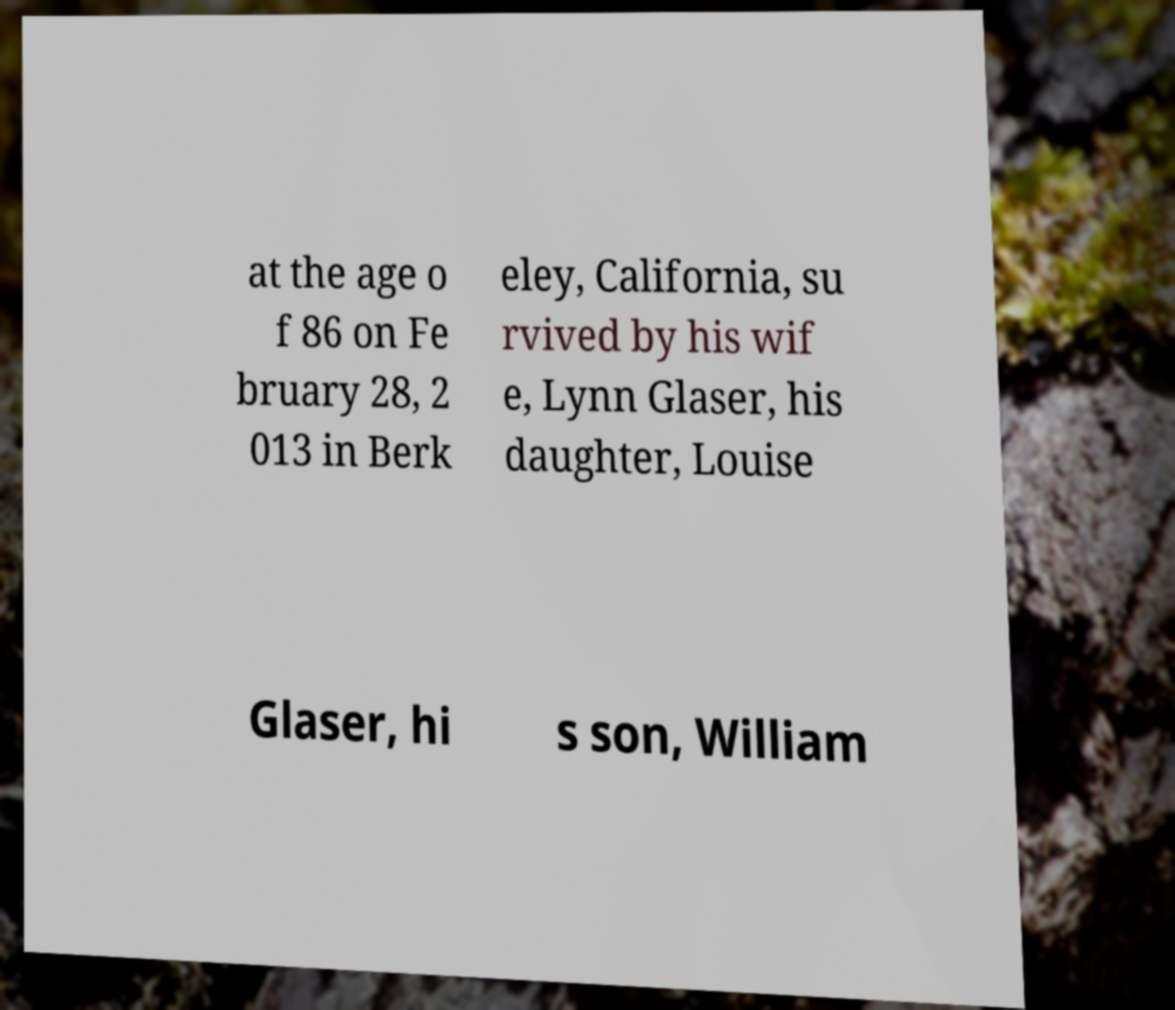Please identify and transcribe the text found in this image. at the age o f 86 on Fe bruary 28, 2 013 in Berk eley, California, su rvived by his wif e, Lynn Glaser, his daughter, Louise Glaser, hi s son, William 